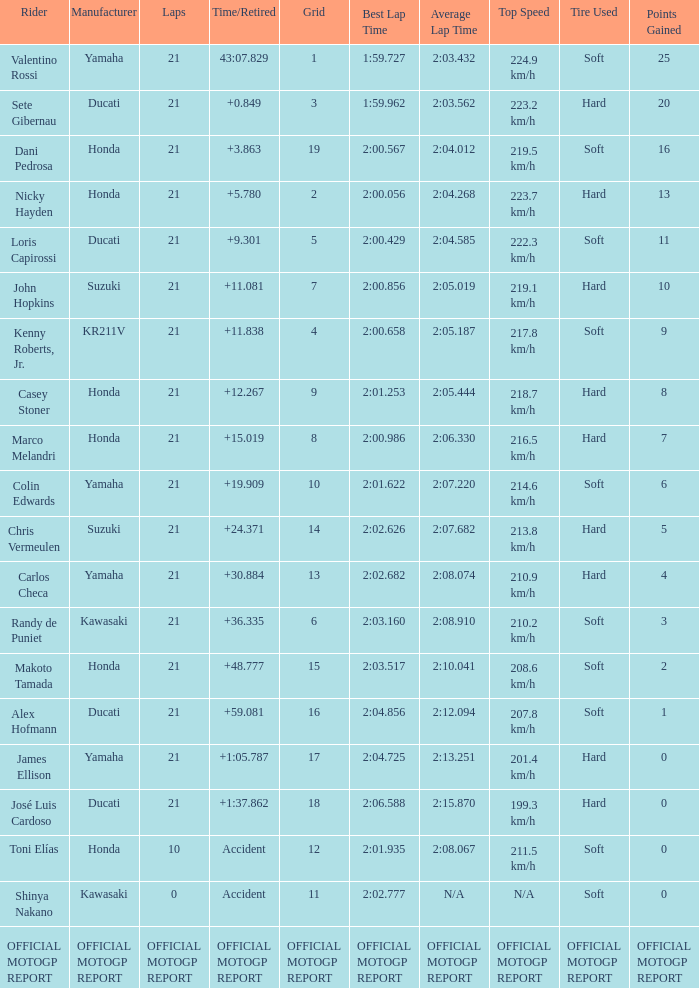WWhich rder had a vehicle manufactured by kr211v? Kenny Roberts, Jr. 